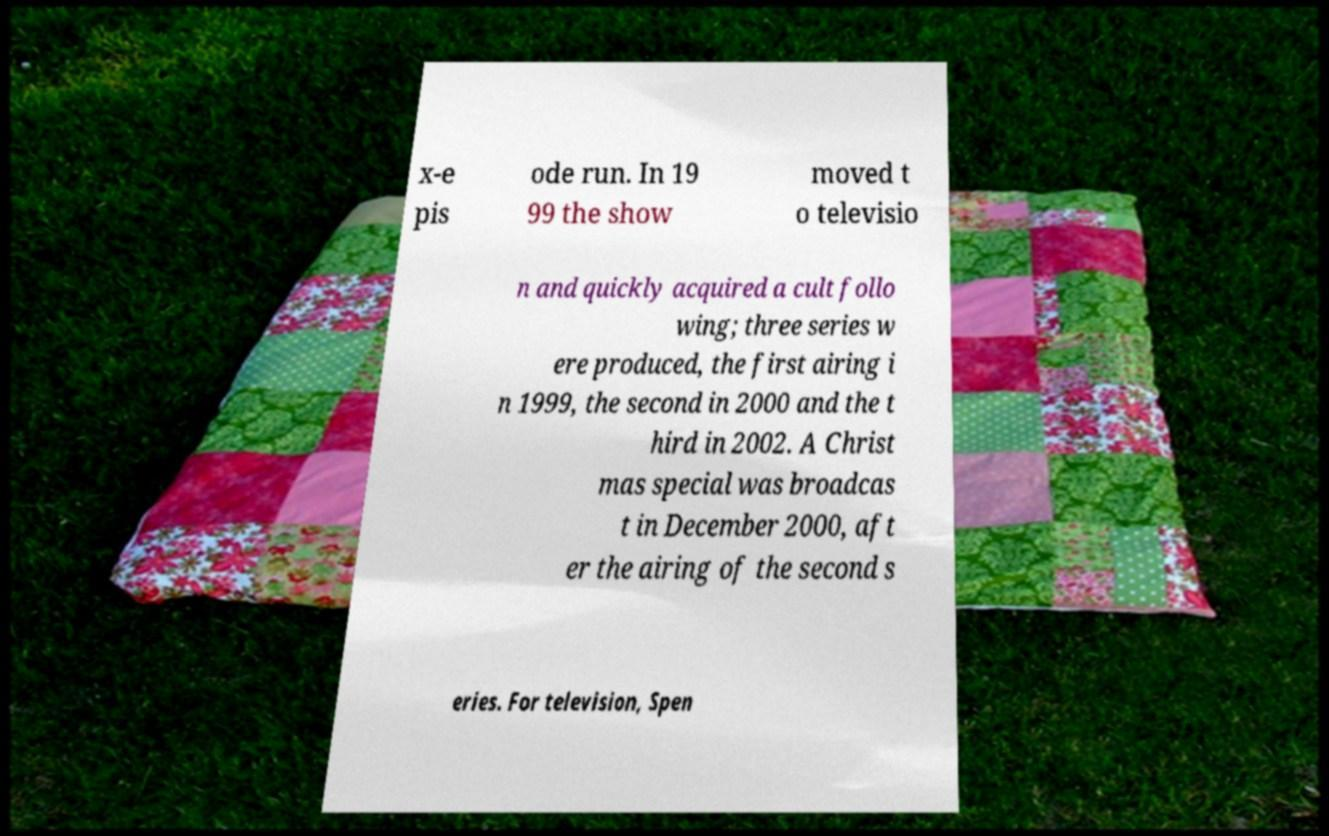There's text embedded in this image that I need extracted. Can you transcribe it verbatim? x-e pis ode run. In 19 99 the show moved t o televisio n and quickly acquired a cult follo wing; three series w ere produced, the first airing i n 1999, the second in 2000 and the t hird in 2002. A Christ mas special was broadcas t in December 2000, aft er the airing of the second s eries. For television, Spen 